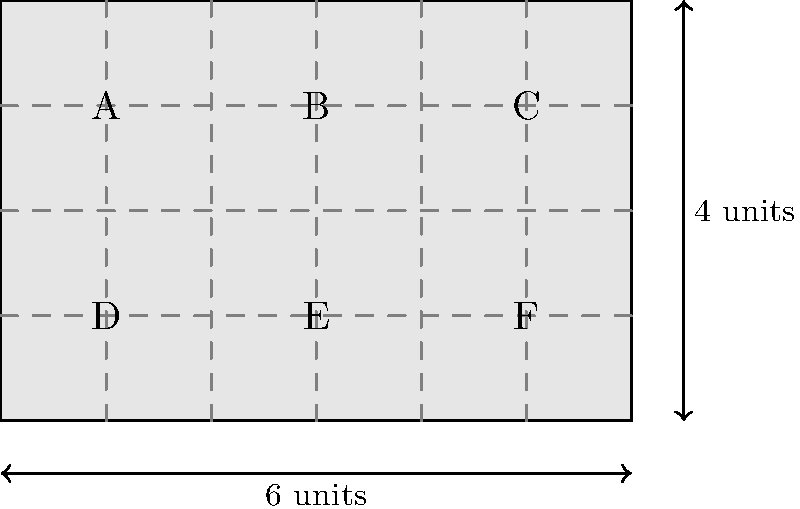In the Linear B tablet layout shown above, symbols A, B, and C are arranged in the top row, while D, E, and F are in the bottom row. If the tablet measures 6 units in width and 4 units in height, what is the area of the rectangle formed by connecting the centers of symbols A, C, E, and F? To solve this problem, we need to follow these steps:

1. Identify the coordinates of the symbols:
   A: (1, 3)
   C: (5, 3)
   E: (3, 1)
   F: (5, 1)

2. Calculate the width of the rectangle:
   The width is the distance between A and C, which is 4 units (5 - 1 = 4).

3. Calculate the height of the rectangle:
   The height is the distance between C and F, which is 2 units (3 - 1 = 2).

4. Apply the formula for the area of a rectangle:
   $$ \text{Area} = \text{width} \times \text{height} $$
   $$ \text{Area} = 4 \times 2 = 8 \text{ square units} $$

Therefore, the area of the rectangle formed by connecting the centers of symbols A, C, E, and F is 8 square units.
Answer: 8 square units 